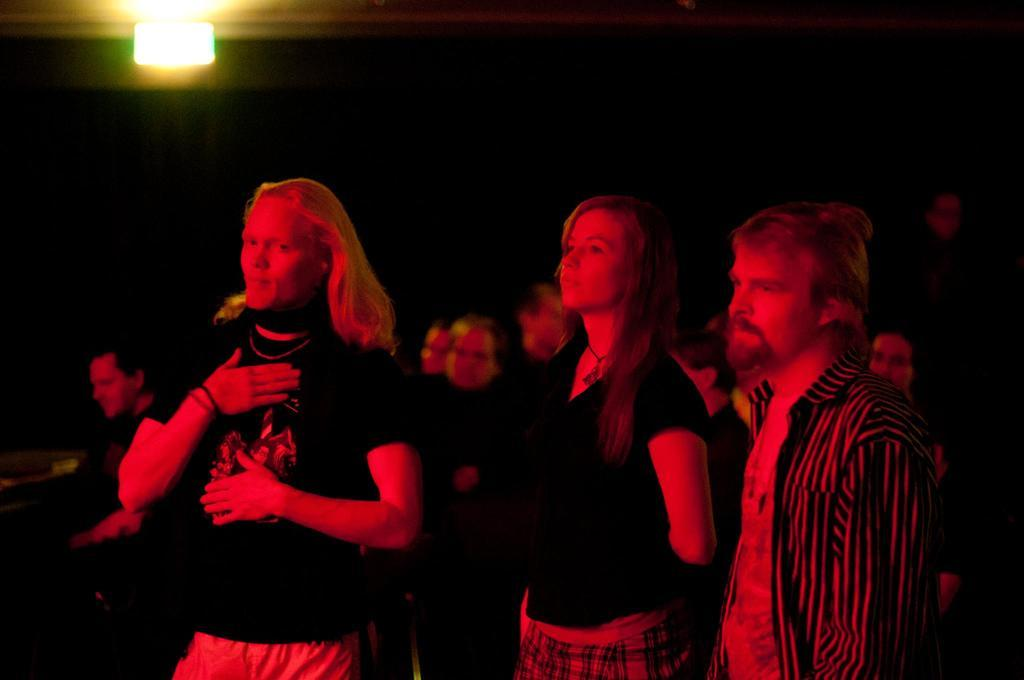What is the overall lighting condition in the image? The image is dark. Can you describe the people in the image? There are people standing in the image, and they are facing towards the left side. Is there any source of light in the image? Yes, there is a light visible at the top of the image. What type of toy can be seen in the hands of the people in the image? There is no toy visible in the hands of the people in the image. What material is the giraffe made of in the image? There is no giraffe present in the image. 